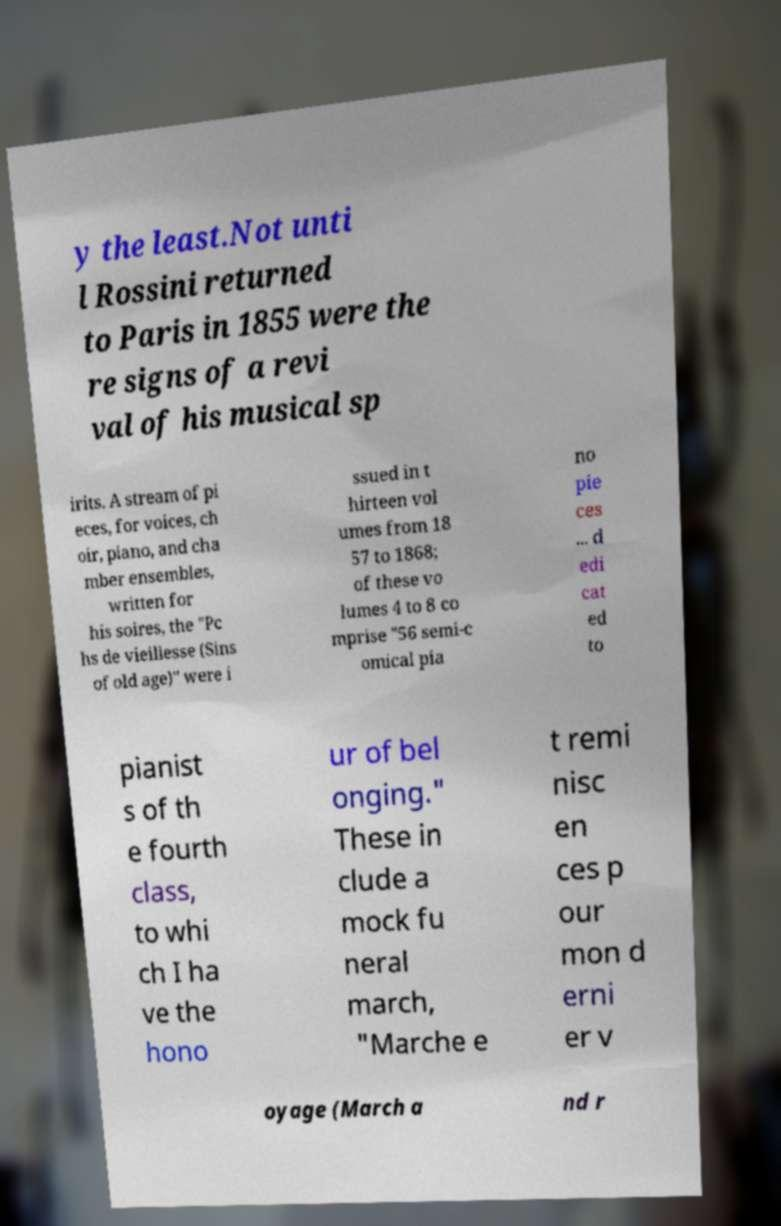Could you assist in decoding the text presented in this image and type it out clearly? y the least.Not unti l Rossini returned to Paris in 1855 were the re signs of a revi val of his musical sp irits. A stream of pi eces, for voices, ch oir, piano, and cha mber ensembles, written for his soires, the "Pc hs de vieillesse (Sins of old age)" were i ssued in t hirteen vol umes from 18 57 to 1868; of these vo lumes 4 to 8 co mprise "56 semi-c omical pia no pie ces ... d edi cat ed to pianist s of th e fourth class, to whi ch I ha ve the hono ur of bel onging." These in clude a mock fu neral march, "Marche e t remi nisc en ces p our mon d erni er v oyage (March a nd r 